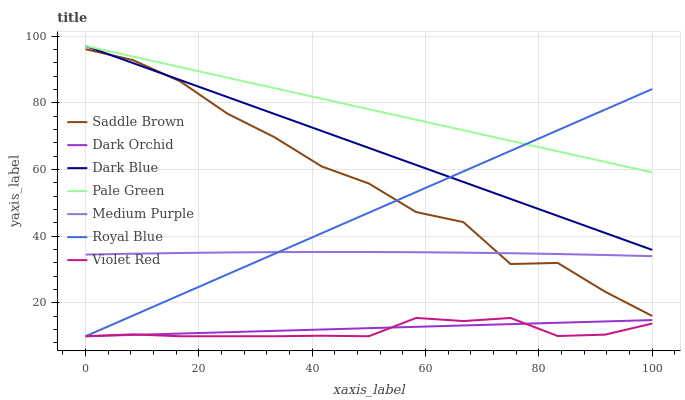Does Violet Red have the minimum area under the curve?
Answer yes or no. Yes. Does Pale Green have the maximum area under the curve?
Answer yes or no. Yes. Does Royal Blue have the minimum area under the curve?
Answer yes or no. No. Does Royal Blue have the maximum area under the curve?
Answer yes or no. No. Is Dark Orchid the smoothest?
Answer yes or no. Yes. Is Saddle Brown the roughest?
Answer yes or no. Yes. Is Royal Blue the smoothest?
Answer yes or no. No. Is Royal Blue the roughest?
Answer yes or no. No. Does Violet Red have the lowest value?
Answer yes or no. Yes. Does Medium Purple have the lowest value?
Answer yes or no. No. Does Pale Green have the highest value?
Answer yes or no. Yes. Does Royal Blue have the highest value?
Answer yes or no. No. Is Violet Red less than Medium Purple?
Answer yes or no. Yes. Is Pale Green greater than Saddle Brown?
Answer yes or no. Yes. Does Royal Blue intersect Saddle Brown?
Answer yes or no. Yes. Is Royal Blue less than Saddle Brown?
Answer yes or no. No. Is Royal Blue greater than Saddle Brown?
Answer yes or no. No. Does Violet Red intersect Medium Purple?
Answer yes or no. No. 